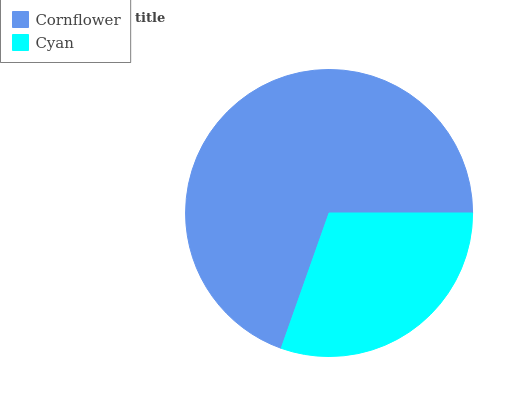Is Cyan the minimum?
Answer yes or no. Yes. Is Cornflower the maximum?
Answer yes or no. Yes. Is Cyan the maximum?
Answer yes or no. No. Is Cornflower greater than Cyan?
Answer yes or no. Yes. Is Cyan less than Cornflower?
Answer yes or no. Yes. Is Cyan greater than Cornflower?
Answer yes or no. No. Is Cornflower less than Cyan?
Answer yes or no. No. Is Cornflower the high median?
Answer yes or no. Yes. Is Cyan the low median?
Answer yes or no. Yes. Is Cyan the high median?
Answer yes or no. No. Is Cornflower the low median?
Answer yes or no. No. 